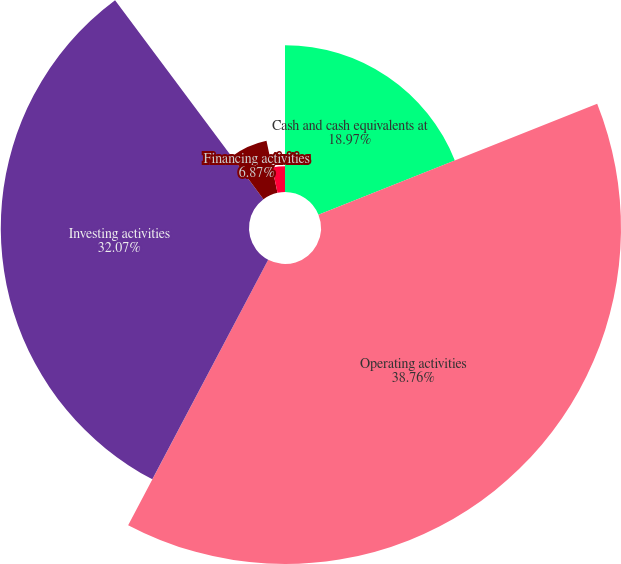Convert chart. <chart><loc_0><loc_0><loc_500><loc_500><pie_chart><fcel>Cash and cash equivalents at<fcel>Operating activities<fcel>Investing activities<fcel>Financing activities<fcel>Net increase in cash and cash<nl><fcel>18.97%<fcel>38.76%<fcel>32.07%<fcel>6.87%<fcel>3.33%<nl></chart> 